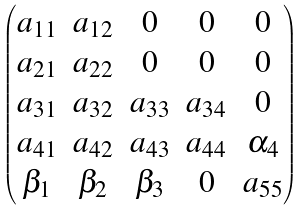Convert formula to latex. <formula><loc_0><loc_0><loc_500><loc_500>\begin{pmatrix} a _ { 1 1 } & a _ { 1 2 } & 0 & 0 & 0 \\ a _ { 2 1 } & a _ { 2 2 } & 0 & 0 & 0 \\ a _ { 3 1 } & a _ { 3 2 } & a _ { 3 3 } & a _ { 3 4 } & 0 \\ a _ { 4 1 } & a _ { 4 2 } & a _ { 4 3 } & a _ { 4 4 } & \alpha _ { 4 } \\ \beta _ { 1 } & \beta _ { 2 } & \beta _ { 3 } & 0 & a _ { 5 5 } \\ \end{pmatrix}</formula> 